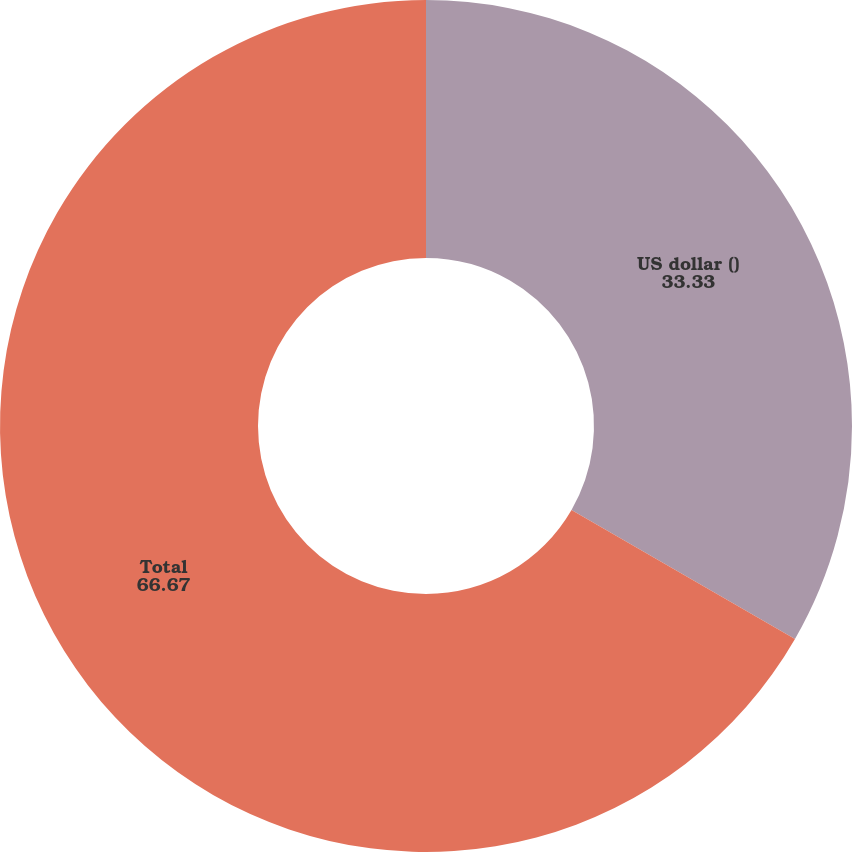<chart> <loc_0><loc_0><loc_500><loc_500><pie_chart><fcel>US dollar ()<fcel>Total<nl><fcel>33.33%<fcel>66.67%<nl></chart> 